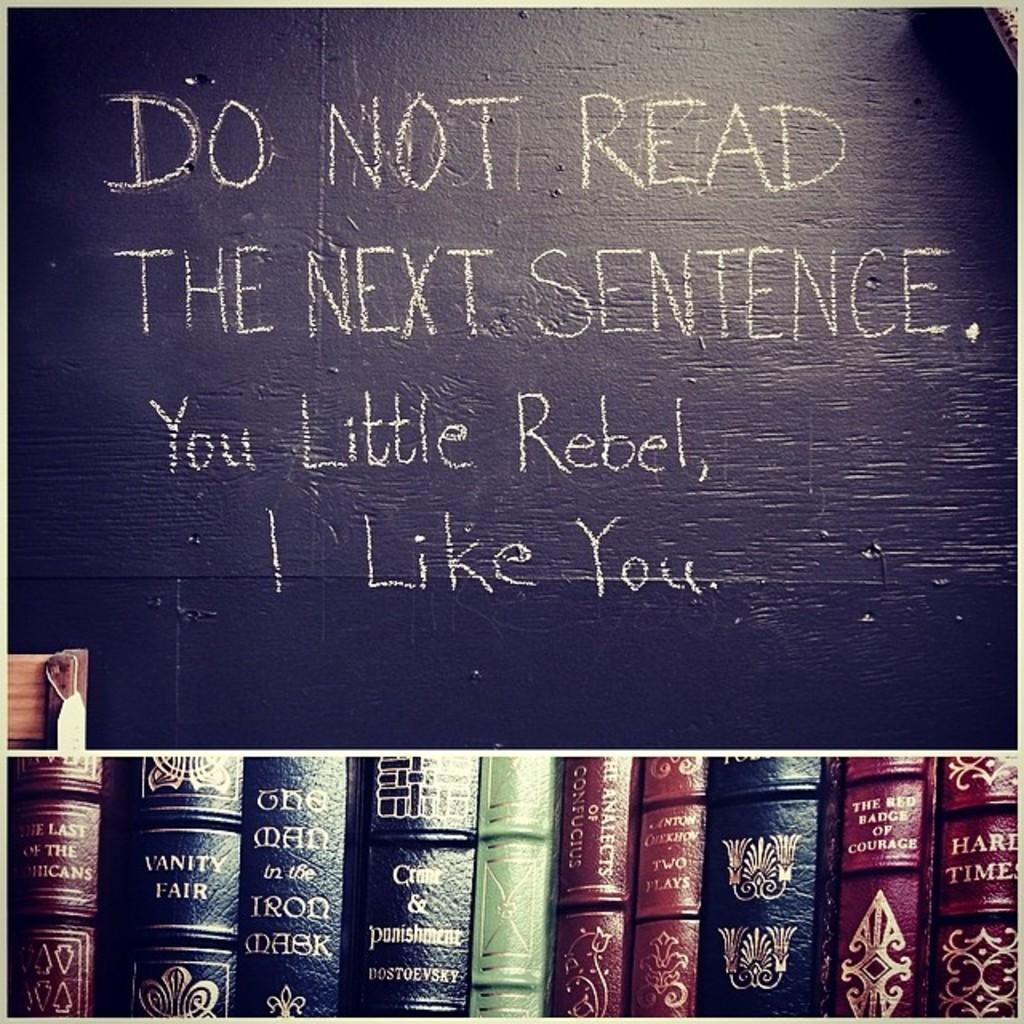<image>
Render a clear and concise summary of the photo. A large black board the states DO NOT READ THE NEXT SENTENCE. 